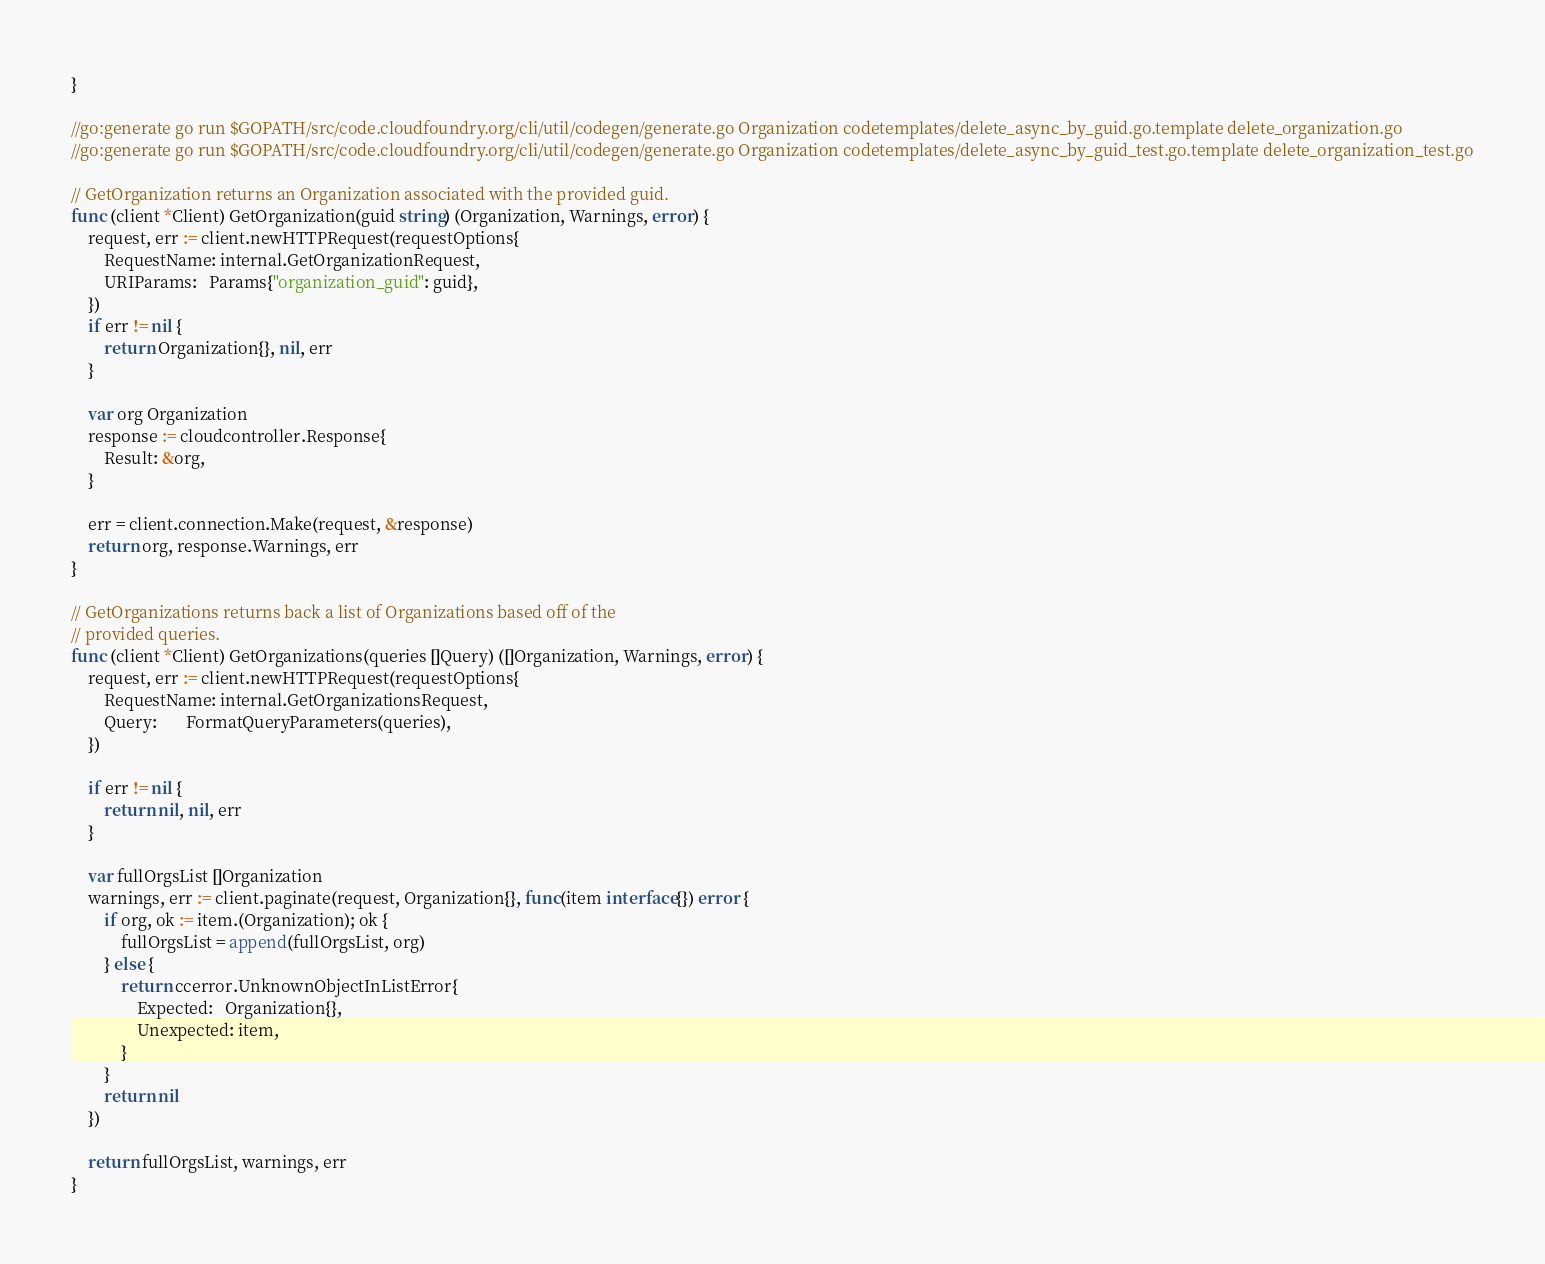Convert code to text. <code><loc_0><loc_0><loc_500><loc_500><_Go_>}

//go:generate go run $GOPATH/src/code.cloudfoundry.org/cli/util/codegen/generate.go Organization codetemplates/delete_async_by_guid.go.template delete_organization.go
//go:generate go run $GOPATH/src/code.cloudfoundry.org/cli/util/codegen/generate.go Organization codetemplates/delete_async_by_guid_test.go.template delete_organization_test.go

// GetOrganization returns an Organization associated with the provided guid.
func (client *Client) GetOrganization(guid string) (Organization, Warnings, error) {
	request, err := client.newHTTPRequest(requestOptions{
		RequestName: internal.GetOrganizationRequest,
		URIParams:   Params{"organization_guid": guid},
	})
	if err != nil {
		return Organization{}, nil, err
	}

	var org Organization
	response := cloudcontroller.Response{
		Result: &org,
	}

	err = client.connection.Make(request, &response)
	return org, response.Warnings, err
}

// GetOrganizations returns back a list of Organizations based off of the
// provided queries.
func (client *Client) GetOrganizations(queries []Query) ([]Organization, Warnings, error) {
	request, err := client.newHTTPRequest(requestOptions{
		RequestName: internal.GetOrganizationsRequest,
		Query:       FormatQueryParameters(queries),
	})

	if err != nil {
		return nil, nil, err
	}

	var fullOrgsList []Organization
	warnings, err := client.paginate(request, Organization{}, func(item interface{}) error {
		if org, ok := item.(Organization); ok {
			fullOrgsList = append(fullOrgsList, org)
		} else {
			return ccerror.UnknownObjectInListError{
				Expected:   Organization{},
				Unexpected: item,
			}
		}
		return nil
	})

	return fullOrgsList, warnings, err
}
</code> 